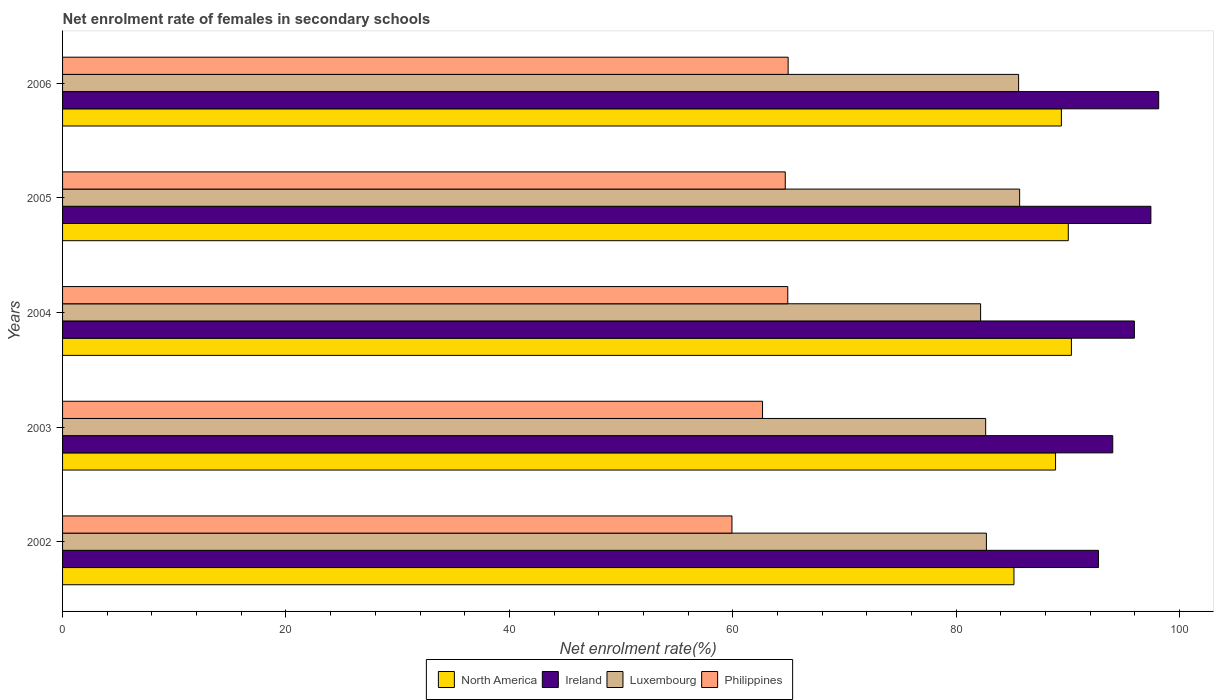How many different coloured bars are there?
Keep it short and to the point. 4. How many groups of bars are there?
Offer a very short reply. 5. Are the number of bars per tick equal to the number of legend labels?
Your answer should be very brief. Yes. Are the number of bars on each tick of the Y-axis equal?
Your answer should be compact. Yes. How many bars are there on the 5th tick from the bottom?
Offer a very short reply. 4. What is the net enrolment rate of females in secondary schools in Luxembourg in 2002?
Offer a very short reply. 82.71. Across all years, what is the maximum net enrolment rate of females in secondary schools in Philippines?
Keep it short and to the point. 64.96. Across all years, what is the minimum net enrolment rate of females in secondary schools in North America?
Provide a short and direct response. 85.17. In which year was the net enrolment rate of females in secondary schools in Philippines minimum?
Provide a succinct answer. 2002. What is the total net enrolment rate of females in secondary schools in Ireland in the graph?
Give a very brief answer. 478.27. What is the difference between the net enrolment rate of females in secondary schools in Luxembourg in 2002 and that in 2004?
Keep it short and to the point. 0.52. What is the difference between the net enrolment rate of females in secondary schools in Luxembourg in 2005 and the net enrolment rate of females in secondary schools in Ireland in 2003?
Your response must be concise. -8.34. What is the average net enrolment rate of females in secondary schools in Philippines per year?
Offer a terse response. 63.43. In the year 2003, what is the difference between the net enrolment rate of females in secondary schools in North America and net enrolment rate of females in secondary schools in Luxembourg?
Your answer should be compact. 6.26. In how many years, is the net enrolment rate of females in secondary schools in Luxembourg greater than 24 %?
Your answer should be very brief. 5. What is the ratio of the net enrolment rate of females in secondary schools in Ireland in 2005 to that in 2006?
Provide a short and direct response. 0.99. Is the net enrolment rate of females in secondary schools in Luxembourg in 2004 less than that in 2005?
Your response must be concise. Yes. Is the difference between the net enrolment rate of females in secondary schools in North America in 2003 and 2004 greater than the difference between the net enrolment rate of females in secondary schools in Luxembourg in 2003 and 2004?
Offer a terse response. No. What is the difference between the highest and the second highest net enrolment rate of females in secondary schools in Ireland?
Your answer should be very brief. 0.7. What is the difference between the highest and the lowest net enrolment rate of females in secondary schools in North America?
Your answer should be very brief. 5.14. In how many years, is the net enrolment rate of females in secondary schools in Ireland greater than the average net enrolment rate of females in secondary schools in Ireland taken over all years?
Your response must be concise. 3. What does the 2nd bar from the top in 2005 represents?
Your response must be concise. Luxembourg. What does the 3rd bar from the bottom in 2005 represents?
Offer a terse response. Luxembourg. Is it the case that in every year, the sum of the net enrolment rate of females in secondary schools in North America and net enrolment rate of females in secondary schools in Ireland is greater than the net enrolment rate of females in secondary schools in Luxembourg?
Make the answer very short. Yes. How many bars are there?
Offer a terse response. 20. Are all the bars in the graph horizontal?
Offer a very short reply. Yes. How many years are there in the graph?
Ensure brevity in your answer.  5. What is the difference between two consecutive major ticks on the X-axis?
Give a very brief answer. 20. Does the graph contain any zero values?
Give a very brief answer. No. How many legend labels are there?
Offer a terse response. 4. What is the title of the graph?
Offer a terse response. Net enrolment rate of females in secondary schools. What is the label or title of the X-axis?
Your answer should be compact. Net enrolment rate(%). What is the Net enrolment rate(%) of North America in 2002?
Your answer should be very brief. 85.17. What is the Net enrolment rate(%) in Ireland in 2002?
Make the answer very short. 92.74. What is the Net enrolment rate(%) in Luxembourg in 2002?
Offer a terse response. 82.71. What is the Net enrolment rate(%) of Philippines in 2002?
Ensure brevity in your answer.  59.93. What is the Net enrolment rate(%) of North America in 2003?
Your response must be concise. 88.9. What is the Net enrolment rate(%) of Ireland in 2003?
Your answer should be compact. 94.02. What is the Net enrolment rate(%) in Luxembourg in 2003?
Offer a terse response. 82.64. What is the Net enrolment rate(%) of Philippines in 2003?
Your response must be concise. 62.67. What is the Net enrolment rate(%) in North America in 2004?
Offer a terse response. 90.32. What is the Net enrolment rate(%) in Ireland in 2004?
Offer a very short reply. 95.95. What is the Net enrolment rate(%) of Luxembourg in 2004?
Your answer should be very brief. 82.19. What is the Net enrolment rate(%) in Philippines in 2004?
Your answer should be very brief. 64.92. What is the Net enrolment rate(%) in North America in 2005?
Provide a succinct answer. 90.04. What is the Net enrolment rate(%) in Ireland in 2005?
Your answer should be compact. 97.43. What is the Net enrolment rate(%) of Luxembourg in 2005?
Provide a succinct answer. 85.68. What is the Net enrolment rate(%) of Philippines in 2005?
Your response must be concise. 64.7. What is the Net enrolment rate(%) in North America in 2006?
Your answer should be very brief. 89.42. What is the Net enrolment rate(%) in Ireland in 2006?
Your answer should be compact. 98.13. What is the Net enrolment rate(%) in Luxembourg in 2006?
Provide a succinct answer. 85.59. What is the Net enrolment rate(%) in Philippines in 2006?
Make the answer very short. 64.96. Across all years, what is the maximum Net enrolment rate(%) in North America?
Offer a very short reply. 90.32. Across all years, what is the maximum Net enrolment rate(%) of Ireland?
Your answer should be compact. 98.13. Across all years, what is the maximum Net enrolment rate(%) of Luxembourg?
Keep it short and to the point. 85.68. Across all years, what is the maximum Net enrolment rate(%) of Philippines?
Provide a short and direct response. 64.96. Across all years, what is the minimum Net enrolment rate(%) of North America?
Provide a succinct answer. 85.17. Across all years, what is the minimum Net enrolment rate(%) in Ireland?
Ensure brevity in your answer.  92.74. Across all years, what is the minimum Net enrolment rate(%) in Luxembourg?
Provide a succinct answer. 82.19. Across all years, what is the minimum Net enrolment rate(%) in Philippines?
Your answer should be very brief. 59.93. What is the total Net enrolment rate(%) of North America in the graph?
Keep it short and to the point. 443.84. What is the total Net enrolment rate(%) of Ireland in the graph?
Make the answer very short. 478.27. What is the total Net enrolment rate(%) of Luxembourg in the graph?
Provide a succinct answer. 418.8. What is the total Net enrolment rate(%) in Philippines in the graph?
Your answer should be compact. 317.17. What is the difference between the Net enrolment rate(%) of North America in 2002 and that in 2003?
Your response must be concise. -3.73. What is the difference between the Net enrolment rate(%) in Ireland in 2002 and that in 2003?
Give a very brief answer. -1.28. What is the difference between the Net enrolment rate(%) in Luxembourg in 2002 and that in 2003?
Keep it short and to the point. 0.07. What is the difference between the Net enrolment rate(%) of Philippines in 2002 and that in 2003?
Provide a succinct answer. -2.74. What is the difference between the Net enrolment rate(%) in North America in 2002 and that in 2004?
Your response must be concise. -5.14. What is the difference between the Net enrolment rate(%) in Ireland in 2002 and that in 2004?
Your response must be concise. -3.22. What is the difference between the Net enrolment rate(%) in Luxembourg in 2002 and that in 2004?
Provide a short and direct response. 0.52. What is the difference between the Net enrolment rate(%) in Philippines in 2002 and that in 2004?
Keep it short and to the point. -5. What is the difference between the Net enrolment rate(%) of North America in 2002 and that in 2005?
Make the answer very short. -4.87. What is the difference between the Net enrolment rate(%) in Ireland in 2002 and that in 2005?
Make the answer very short. -4.69. What is the difference between the Net enrolment rate(%) in Luxembourg in 2002 and that in 2005?
Offer a very short reply. -2.98. What is the difference between the Net enrolment rate(%) of Philippines in 2002 and that in 2005?
Your response must be concise. -4.77. What is the difference between the Net enrolment rate(%) of North America in 2002 and that in 2006?
Give a very brief answer. -4.25. What is the difference between the Net enrolment rate(%) of Ireland in 2002 and that in 2006?
Your response must be concise. -5.39. What is the difference between the Net enrolment rate(%) of Luxembourg in 2002 and that in 2006?
Ensure brevity in your answer.  -2.88. What is the difference between the Net enrolment rate(%) of Philippines in 2002 and that in 2006?
Your answer should be compact. -5.03. What is the difference between the Net enrolment rate(%) in North America in 2003 and that in 2004?
Offer a terse response. -1.42. What is the difference between the Net enrolment rate(%) in Ireland in 2003 and that in 2004?
Your response must be concise. -1.94. What is the difference between the Net enrolment rate(%) in Luxembourg in 2003 and that in 2004?
Make the answer very short. 0.45. What is the difference between the Net enrolment rate(%) in Philippines in 2003 and that in 2004?
Offer a very short reply. -2.26. What is the difference between the Net enrolment rate(%) in North America in 2003 and that in 2005?
Your answer should be compact. -1.14. What is the difference between the Net enrolment rate(%) of Ireland in 2003 and that in 2005?
Provide a succinct answer. -3.41. What is the difference between the Net enrolment rate(%) in Luxembourg in 2003 and that in 2005?
Offer a terse response. -3.04. What is the difference between the Net enrolment rate(%) of Philippines in 2003 and that in 2005?
Offer a very short reply. -2.03. What is the difference between the Net enrolment rate(%) of North America in 2003 and that in 2006?
Offer a terse response. -0.52. What is the difference between the Net enrolment rate(%) in Ireland in 2003 and that in 2006?
Your answer should be very brief. -4.11. What is the difference between the Net enrolment rate(%) in Luxembourg in 2003 and that in 2006?
Your answer should be very brief. -2.95. What is the difference between the Net enrolment rate(%) of Philippines in 2003 and that in 2006?
Give a very brief answer. -2.29. What is the difference between the Net enrolment rate(%) in North America in 2004 and that in 2005?
Provide a succinct answer. 0.28. What is the difference between the Net enrolment rate(%) in Ireland in 2004 and that in 2005?
Your answer should be very brief. -1.48. What is the difference between the Net enrolment rate(%) of Luxembourg in 2004 and that in 2005?
Give a very brief answer. -3.49. What is the difference between the Net enrolment rate(%) in Philippines in 2004 and that in 2005?
Give a very brief answer. 0.22. What is the difference between the Net enrolment rate(%) of North America in 2004 and that in 2006?
Your response must be concise. 0.9. What is the difference between the Net enrolment rate(%) of Ireland in 2004 and that in 2006?
Provide a succinct answer. -2.18. What is the difference between the Net enrolment rate(%) in Luxembourg in 2004 and that in 2006?
Provide a short and direct response. -3.4. What is the difference between the Net enrolment rate(%) in Philippines in 2004 and that in 2006?
Offer a very short reply. -0.03. What is the difference between the Net enrolment rate(%) of North America in 2005 and that in 2006?
Keep it short and to the point. 0.62. What is the difference between the Net enrolment rate(%) in Ireland in 2005 and that in 2006?
Offer a very short reply. -0.7. What is the difference between the Net enrolment rate(%) in Luxembourg in 2005 and that in 2006?
Give a very brief answer. 0.09. What is the difference between the Net enrolment rate(%) in Philippines in 2005 and that in 2006?
Your answer should be compact. -0.26. What is the difference between the Net enrolment rate(%) of North America in 2002 and the Net enrolment rate(%) of Ireland in 2003?
Offer a terse response. -8.85. What is the difference between the Net enrolment rate(%) in North America in 2002 and the Net enrolment rate(%) in Luxembourg in 2003?
Ensure brevity in your answer.  2.53. What is the difference between the Net enrolment rate(%) in North America in 2002 and the Net enrolment rate(%) in Philippines in 2003?
Your answer should be compact. 22.51. What is the difference between the Net enrolment rate(%) of Ireland in 2002 and the Net enrolment rate(%) of Luxembourg in 2003?
Give a very brief answer. 10.1. What is the difference between the Net enrolment rate(%) in Ireland in 2002 and the Net enrolment rate(%) in Philippines in 2003?
Ensure brevity in your answer.  30.07. What is the difference between the Net enrolment rate(%) in Luxembourg in 2002 and the Net enrolment rate(%) in Philippines in 2003?
Provide a succinct answer. 20.04. What is the difference between the Net enrolment rate(%) in North America in 2002 and the Net enrolment rate(%) in Ireland in 2004?
Your response must be concise. -10.78. What is the difference between the Net enrolment rate(%) of North America in 2002 and the Net enrolment rate(%) of Luxembourg in 2004?
Provide a short and direct response. 2.98. What is the difference between the Net enrolment rate(%) in North America in 2002 and the Net enrolment rate(%) in Philippines in 2004?
Your answer should be very brief. 20.25. What is the difference between the Net enrolment rate(%) in Ireland in 2002 and the Net enrolment rate(%) in Luxembourg in 2004?
Give a very brief answer. 10.55. What is the difference between the Net enrolment rate(%) in Ireland in 2002 and the Net enrolment rate(%) in Philippines in 2004?
Keep it short and to the point. 27.81. What is the difference between the Net enrolment rate(%) in Luxembourg in 2002 and the Net enrolment rate(%) in Philippines in 2004?
Your answer should be compact. 17.78. What is the difference between the Net enrolment rate(%) of North America in 2002 and the Net enrolment rate(%) of Ireland in 2005?
Your response must be concise. -12.26. What is the difference between the Net enrolment rate(%) in North America in 2002 and the Net enrolment rate(%) in Luxembourg in 2005?
Keep it short and to the point. -0.51. What is the difference between the Net enrolment rate(%) of North America in 2002 and the Net enrolment rate(%) of Philippines in 2005?
Offer a terse response. 20.47. What is the difference between the Net enrolment rate(%) in Ireland in 2002 and the Net enrolment rate(%) in Luxembourg in 2005?
Offer a terse response. 7.06. What is the difference between the Net enrolment rate(%) in Ireland in 2002 and the Net enrolment rate(%) in Philippines in 2005?
Your answer should be very brief. 28.04. What is the difference between the Net enrolment rate(%) in Luxembourg in 2002 and the Net enrolment rate(%) in Philippines in 2005?
Your answer should be very brief. 18.01. What is the difference between the Net enrolment rate(%) of North America in 2002 and the Net enrolment rate(%) of Ireland in 2006?
Keep it short and to the point. -12.96. What is the difference between the Net enrolment rate(%) of North America in 2002 and the Net enrolment rate(%) of Luxembourg in 2006?
Provide a short and direct response. -0.42. What is the difference between the Net enrolment rate(%) of North America in 2002 and the Net enrolment rate(%) of Philippines in 2006?
Offer a terse response. 20.21. What is the difference between the Net enrolment rate(%) of Ireland in 2002 and the Net enrolment rate(%) of Luxembourg in 2006?
Give a very brief answer. 7.15. What is the difference between the Net enrolment rate(%) of Ireland in 2002 and the Net enrolment rate(%) of Philippines in 2006?
Your response must be concise. 27.78. What is the difference between the Net enrolment rate(%) in Luxembourg in 2002 and the Net enrolment rate(%) in Philippines in 2006?
Provide a succinct answer. 17.75. What is the difference between the Net enrolment rate(%) of North America in 2003 and the Net enrolment rate(%) of Ireland in 2004?
Your response must be concise. -7.06. What is the difference between the Net enrolment rate(%) of North America in 2003 and the Net enrolment rate(%) of Luxembourg in 2004?
Offer a very short reply. 6.71. What is the difference between the Net enrolment rate(%) of North America in 2003 and the Net enrolment rate(%) of Philippines in 2004?
Your answer should be very brief. 23.97. What is the difference between the Net enrolment rate(%) in Ireland in 2003 and the Net enrolment rate(%) in Luxembourg in 2004?
Your answer should be very brief. 11.83. What is the difference between the Net enrolment rate(%) of Ireland in 2003 and the Net enrolment rate(%) of Philippines in 2004?
Your answer should be very brief. 29.09. What is the difference between the Net enrolment rate(%) in Luxembourg in 2003 and the Net enrolment rate(%) in Philippines in 2004?
Your response must be concise. 17.72. What is the difference between the Net enrolment rate(%) in North America in 2003 and the Net enrolment rate(%) in Ireland in 2005?
Provide a short and direct response. -8.53. What is the difference between the Net enrolment rate(%) of North America in 2003 and the Net enrolment rate(%) of Luxembourg in 2005?
Your response must be concise. 3.22. What is the difference between the Net enrolment rate(%) in North America in 2003 and the Net enrolment rate(%) in Philippines in 2005?
Your answer should be very brief. 24.2. What is the difference between the Net enrolment rate(%) in Ireland in 2003 and the Net enrolment rate(%) in Luxembourg in 2005?
Your answer should be compact. 8.34. What is the difference between the Net enrolment rate(%) of Ireland in 2003 and the Net enrolment rate(%) of Philippines in 2005?
Offer a terse response. 29.32. What is the difference between the Net enrolment rate(%) in Luxembourg in 2003 and the Net enrolment rate(%) in Philippines in 2005?
Your answer should be compact. 17.94. What is the difference between the Net enrolment rate(%) in North America in 2003 and the Net enrolment rate(%) in Ireland in 2006?
Offer a terse response. -9.23. What is the difference between the Net enrolment rate(%) of North America in 2003 and the Net enrolment rate(%) of Luxembourg in 2006?
Ensure brevity in your answer.  3.31. What is the difference between the Net enrolment rate(%) in North America in 2003 and the Net enrolment rate(%) in Philippines in 2006?
Ensure brevity in your answer.  23.94. What is the difference between the Net enrolment rate(%) of Ireland in 2003 and the Net enrolment rate(%) of Luxembourg in 2006?
Give a very brief answer. 8.43. What is the difference between the Net enrolment rate(%) of Ireland in 2003 and the Net enrolment rate(%) of Philippines in 2006?
Your answer should be very brief. 29.06. What is the difference between the Net enrolment rate(%) in Luxembourg in 2003 and the Net enrolment rate(%) in Philippines in 2006?
Ensure brevity in your answer.  17.68. What is the difference between the Net enrolment rate(%) in North America in 2004 and the Net enrolment rate(%) in Ireland in 2005?
Make the answer very short. -7.11. What is the difference between the Net enrolment rate(%) in North America in 2004 and the Net enrolment rate(%) in Luxembourg in 2005?
Make the answer very short. 4.63. What is the difference between the Net enrolment rate(%) in North America in 2004 and the Net enrolment rate(%) in Philippines in 2005?
Give a very brief answer. 25.62. What is the difference between the Net enrolment rate(%) of Ireland in 2004 and the Net enrolment rate(%) of Luxembourg in 2005?
Keep it short and to the point. 10.27. What is the difference between the Net enrolment rate(%) in Ireland in 2004 and the Net enrolment rate(%) in Philippines in 2005?
Offer a very short reply. 31.25. What is the difference between the Net enrolment rate(%) of Luxembourg in 2004 and the Net enrolment rate(%) of Philippines in 2005?
Ensure brevity in your answer.  17.49. What is the difference between the Net enrolment rate(%) of North America in 2004 and the Net enrolment rate(%) of Ireland in 2006?
Make the answer very short. -7.81. What is the difference between the Net enrolment rate(%) of North America in 2004 and the Net enrolment rate(%) of Luxembourg in 2006?
Keep it short and to the point. 4.73. What is the difference between the Net enrolment rate(%) of North America in 2004 and the Net enrolment rate(%) of Philippines in 2006?
Your answer should be very brief. 25.36. What is the difference between the Net enrolment rate(%) in Ireland in 2004 and the Net enrolment rate(%) in Luxembourg in 2006?
Give a very brief answer. 10.36. What is the difference between the Net enrolment rate(%) of Ireland in 2004 and the Net enrolment rate(%) of Philippines in 2006?
Keep it short and to the point. 31. What is the difference between the Net enrolment rate(%) of Luxembourg in 2004 and the Net enrolment rate(%) of Philippines in 2006?
Provide a short and direct response. 17.23. What is the difference between the Net enrolment rate(%) of North America in 2005 and the Net enrolment rate(%) of Ireland in 2006?
Provide a succinct answer. -8.09. What is the difference between the Net enrolment rate(%) of North America in 2005 and the Net enrolment rate(%) of Luxembourg in 2006?
Keep it short and to the point. 4.45. What is the difference between the Net enrolment rate(%) in North America in 2005 and the Net enrolment rate(%) in Philippines in 2006?
Provide a succinct answer. 25.08. What is the difference between the Net enrolment rate(%) in Ireland in 2005 and the Net enrolment rate(%) in Luxembourg in 2006?
Ensure brevity in your answer.  11.84. What is the difference between the Net enrolment rate(%) of Ireland in 2005 and the Net enrolment rate(%) of Philippines in 2006?
Your response must be concise. 32.47. What is the difference between the Net enrolment rate(%) of Luxembourg in 2005 and the Net enrolment rate(%) of Philippines in 2006?
Your response must be concise. 20.72. What is the average Net enrolment rate(%) in North America per year?
Your answer should be compact. 88.77. What is the average Net enrolment rate(%) of Ireland per year?
Offer a terse response. 95.65. What is the average Net enrolment rate(%) of Luxembourg per year?
Your response must be concise. 83.76. What is the average Net enrolment rate(%) in Philippines per year?
Offer a terse response. 63.43. In the year 2002, what is the difference between the Net enrolment rate(%) of North America and Net enrolment rate(%) of Ireland?
Ensure brevity in your answer.  -7.57. In the year 2002, what is the difference between the Net enrolment rate(%) in North America and Net enrolment rate(%) in Luxembourg?
Your response must be concise. 2.47. In the year 2002, what is the difference between the Net enrolment rate(%) of North America and Net enrolment rate(%) of Philippines?
Offer a terse response. 25.25. In the year 2002, what is the difference between the Net enrolment rate(%) in Ireland and Net enrolment rate(%) in Luxembourg?
Offer a terse response. 10.03. In the year 2002, what is the difference between the Net enrolment rate(%) of Ireland and Net enrolment rate(%) of Philippines?
Make the answer very short. 32.81. In the year 2002, what is the difference between the Net enrolment rate(%) in Luxembourg and Net enrolment rate(%) in Philippines?
Give a very brief answer. 22.78. In the year 2003, what is the difference between the Net enrolment rate(%) in North America and Net enrolment rate(%) in Ireland?
Make the answer very short. -5.12. In the year 2003, what is the difference between the Net enrolment rate(%) of North America and Net enrolment rate(%) of Luxembourg?
Ensure brevity in your answer.  6.26. In the year 2003, what is the difference between the Net enrolment rate(%) in North America and Net enrolment rate(%) in Philippines?
Make the answer very short. 26.23. In the year 2003, what is the difference between the Net enrolment rate(%) in Ireland and Net enrolment rate(%) in Luxembourg?
Give a very brief answer. 11.38. In the year 2003, what is the difference between the Net enrolment rate(%) of Ireland and Net enrolment rate(%) of Philippines?
Your answer should be very brief. 31.35. In the year 2003, what is the difference between the Net enrolment rate(%) of Luxembourg and Net enrolment rate(%) of Philippines?
Make the answer very short. 19.97. In the year 2004, what is the difference between the Net enrolment rate(%) of North America and Net enrolment rate(%) of Ireland?
Ensure brevity in your answer.  -5.64. In the year 2004, what is the difference between the Net enrolment rate(%) in North America and Net enrolment rate(%) in Luxembourg?
Offer a very short reply. 8.13. In the year 2004, what is the difference between the Net enrolment rate(%) of North America and Net enrolment rate(%) of Philippines?
Offer a terse response. 25.39. In the year 2004, what is the difference between the Net enrolment rate(%) of Ireland and Net enrolment rate(%) of Luxembourg?
Offer a very short reply. 13.77. In the year 2004, what is the difference between the Net enrolment rate(%) of Ireland and Net enrolment rate(%) of Philippines?
Your response must be concise. 31.03. In the year 2004, what is the difference between the Net enrolment rate(%) of Luxembourg and Net enrolment rate(%) of Philippines?
Give a very brief answer. 17.26. In the year 2005, what is the difference between the Net enrolment rate(%) of North America and Net enrolment rate(%) of Ireland?
Give a very brief answer. -7.39. In the year 2005, what is the difference between the Net enrolment rate(%) of North America and Net enrolment rate(%) of Luxembourg?
Give a very brief answer. 4.36. In the year 2005, what is the difference between the Net enrolment rate(%) in North America and Net enrolment rate(%) in Philippines?
Your answer should be very brief. 25.34. In the year 2005, what is the difference between the Net enrolment rate(%) in Ireland and Net enrolment rate(%) in Luxembourg?
Your response must be concise. 11.75. In the year 2005, what is the difference between the Net enrolment rate(%) of Ireland and Net enrolment rate(%) of Philippines?
Keep it short and to the point. 32.73. In the year 2005, what is the difference between the Net enrolment rate(%) in Luxembourg and Net enrolment rate(%) in Philippines?
Make the answer very short. 20.98. In the year 2006, what is the difference between the Net enrolment rate(%) of North America and Net enrolment rate(%) of Ireland?
Ensure brevity in your answer.  -8.71. In the year 2006, what is the difference between the Net enrolment rate(%) in North America and Net enrolment rate(%) in Luxembourg?
Ensure brevity in your answer.  3.83. In the year 2006, what is the difference between the Net enrolment rate(%) in North America and Net enrolment rate(%) in Philippines?
Offer a terse response. 24.46. In the year 2006, what is the difference between the Net enrolment rate(%) in Ireland and Net enrolment rate(%) in Luxembourg?
Your answer should be compact. 12.54. In the year 2006, what is the difference between the Net enrolment rate(%) in Ireland and Net enrolment rate(%) in Philippines?
Your answer should be very brief. 33.17. In the year 2006, what is the difference between the Net enrolment rate(%) in Luxembourg and Net enrolment rate(%) in Philippines?
Provide a short and direct response. 20.63. What is the ratio of the Net enrolment rate(%) of North America in 2002 to that in 2003?
Offer a very short reply. 0.96. What is the ratio of the Net enrolment rate(%) in Ireland in 2002 to that in 2003?
Provide a succinct answer. 0.99. What is the ratio of the Net enrolment rate(%) in Philippines in 2002 to that in 2003?
Provide a succinct answer. 0.96. What is the ratio of the Net enrolment rate(%) in North America in 2002 to that in 2004?
Offer a very short reply. 0.94. What is the ratio of the Net enrolment rate(%) of Ireland in 2002 to that in 2004?
Make the answer very short. 0.97. What is the ratio of the Net enrolment rate(%) of Philippines in 2002 to that in 2004?
Provide a succinct answer. 0.92. What is the ratio of the Net enrolment rate(%) of North America in 2002 to that in 2005?
Offer a terse response. 0.95. What is the ratio of the Net enrolment rate(%) of Ireland in 2002 to that in 2005?
Offer a terse response. 0.95. What is the ratio of the Net enrolment rate(%) in Luxembourg in 2002 to that in 2005?
Ensure brevity in your answer.  0.97. What is the ratio of the Net enrolment rate(%) in Philippines in 2002 to that in 2005?
Offer a very short reply. 0.93. What is the ratio of the Net enrolment rate(%) in North America in 2002 to that in 2006?
Give a very brief answer. 0.95. What is the ratio of the Net enrolment rate(%) of Ireland in 2002 to that in 2006?
Your answer should be very brief. 0.94. What is the ratio of the Net enrolment rate(%) of Luxembourg in 2002 to that in 2006?
Ensure brevity in your answer.  0.97. What is the ratio of the Net enrolment rate(%) in Philippines in 2002 to that in 2006?
Provide a succinct answer. 0.92. What is the ratio of the Net enrolment rate(%) of North America in 2003 to that in 2004?
Offer a terse response. 0.98. What is the ratio of the Net enrolment rate(%) of Ireland in 2003 to that in 2004?
Offer a terse response. 0.98. What is the ratio of the Net enrolment rate(%) of Philippines in 2003 to that in 2004?
Offer a terse response. 0.97. What is the ratio of the Net enrolment rate(%) of North America in 2003 to that in 2005?
Give a very brief answer. 0.99. What is the ratio of the Net enrolment rate(%) of Luxembourg in 2003 to that in 2005?
Your answer should be compact. 0.96. What is the ratio of the Net enrolment rate(%) in Philippines in 2003 to that in 2005?
Provide a short and direct response. 0.97. What is the ratio of the Net enrolment rate(%) of North America in 2003 to that in 2006?
Make the answer very short. 0.99. What is the ratio of the Net enrolment rate(%) of Ireland in 2003 to that in 2006?
Your response must be concise. 0.96. What is the ratio of the Net enrolment rate(%) of Luxembourg in 2003 to that in 2006?
Give a very brief answer. 0.97. What is the ratio of the Net enrolment rate(%) in Philippines in 2003 to that in 2006?
Offer a terse response. 0.96. What is the ratio of the Net enrolment rate(%) in North America in 2004 to that in 2005?
Keep it short and to the point. 1. What is the ratio of the Net enrolment rate(%) in Ireland in 2004 to that in 2005?
Ensure brevity in your answer.  0.98. What is the ratio of the Net enrolment rate(%) in Luxembourg in 2004 to that in 2005?
Your answer should be compact. 0.96. What is the ratio of the Net enrolment rate(%) in Philippines in 2004 to that in 2005?
Give a very brief answer. 1. What is the ratio of the Net enrolment rate(%) of North America in 2004 to that in 2006?
Ensure brevity in your answer.  1.01. What is the ratio of the Net enrolment rate(%) in Ireland in 2004 to that in 2006?
Provide a short and direct response. 0.98. What is the ratio of the Net enrolment rate(%) in Luxembourg in 2004 to that in 2006?
Keep it short and to the point. 0.96. What is the ratio of the Net enrolment rate(%) of Ireland in 2005 to that in 2006?
Provide a short and direct response. 0.99. What is the ratio of the Net enrolment rate(%) in Luxembourg in 2005 to that in 2006?
Your answer should be compact. 1. What is the difference between the highest and the second highest Net enrolment rate(%) of North America?
Make the answer very short. 0.28. What is the difference between the highest and the second highest Net enrolment rate(%) in Ireland?
Ensure brevity in your answer.  0.7. What is the difference between the highest and the second highest Net enrolment rate(%) of Luxembourg?
Keep it short and to the point. 0.09. What is the difference between the highest and the second highest Net enrolment rate(%) in Philippines?
Ensure brevity in your answer.  0.03. What is the difference between the highest and the lowest Net enrolment rate(%) of North America?
Provide a short and direct response. 5.14. What is the difference between the highest and the lowest Net enrolment rate(%) in Ireland?
Provide a short and direct response. 5.39. What is the difference between the highest and the lowest Net enrolment rate(%) of Luxembourg?
Keep it short and to the point. 3.49. What is the difference between the highest and the lowest Net enrolment rate(%) of Philippines?
Make the answer very short. 5.03. 